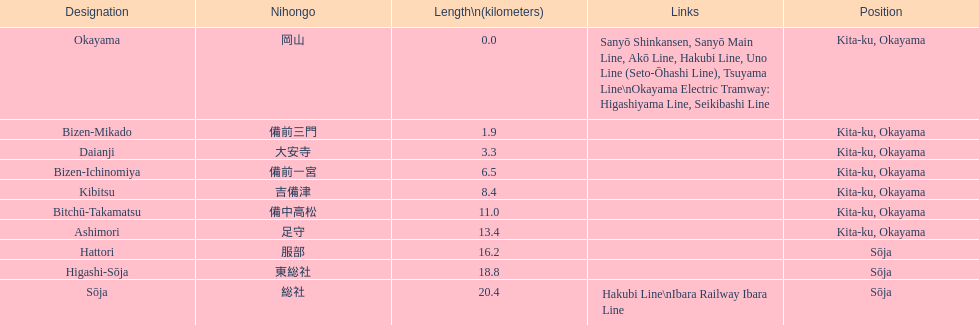How many station are located in kita-ku, okayama? 7. 